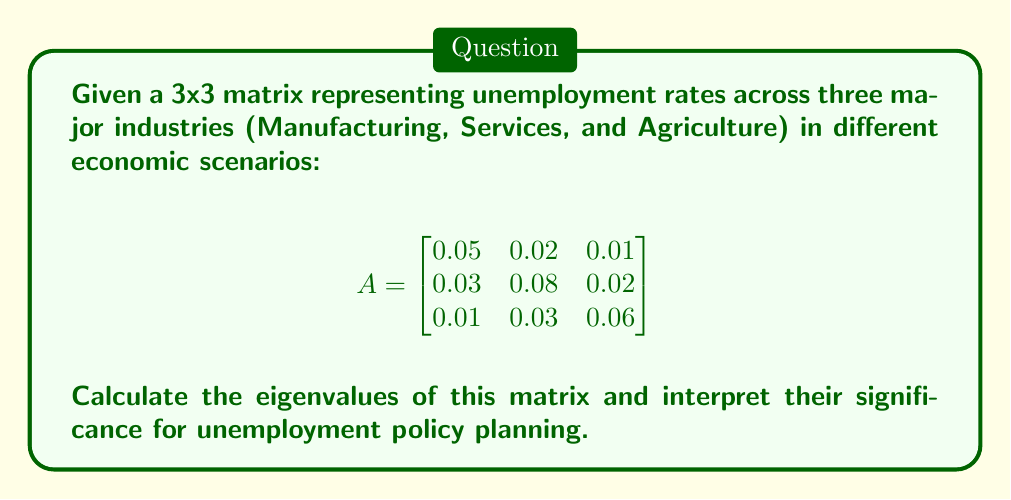Provide a solution to this math problem. To find the eigenvalues of matrix A, we need to solve the characteristic equation:

1) First, we set up the equation: $det(A - \lambda I) = 0$, where $I$ is the 3x3 identity matrix.

2) Expand the determinant:

   $$det\begin{pmatrix}
   0.05-\lambda & 0.02 & 0.01 \\
   0.03 & 0.08-\lambda & 0.02 \\
   0.01 & 0.03 & 0.06-\lambda
   \end{pmatrix} = 0$$

3) Calculate the determinant:

   $(0.05-\lambda)[(0.08-\lambda)(0.06-\lambda)-0.0006] - 0.02[0.03(0.06-\lambda)-0.0002] + 0.01[0.03(0.08-\lambda)-0.0006] = 0$

4) Simplify:

   $-\lambda^3 + 0.19\lambda^2 - 0.0107\lambda + 0.0002 = 0$

5) Solve this cubic equation. The roots are the eigenvalues:

   $\lambda_1 \approx 0.1608$
   $\lambda_2 \approx 0.0246$
   $\lambda_3 \approx 0.0046$

Interpretation: 
- The largest eigenvalue (0.1608) represents the overall trend of unemployment across industries.
- The other eigenvalues indicate secondary and tertiary patterns of unemployment distribution.
- Positive eigenvalues suggest that unemployment rates are interconnected and may amplify each other across industries.
- The policy advisor should focus on strategies that address the dominant unemployment pattern (represented by the largest eigenvalue) while also considering the secondary patterns.
Answer: Eigenvalues: 0.1608, 0.0246, 0.0046. Largest eigenvalue indicates primary unemployment trend for policy focus. 